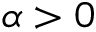Convert formula to latex. <formula><loc_0><loc_0><loc_500><loc_500>\alpha > 0</formula> 